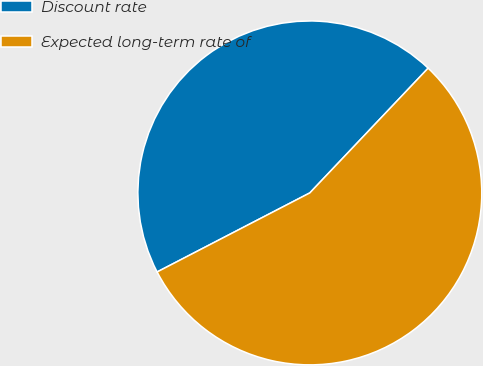Convert chart to OTSL. <chart><loc_0><loc_0><loc_500><loc_500><pie_chart><fcel>Discount rate<fcel>Expected long-term rate of<nl><fcel>44.68%<fcel>55.32%<nl></chart> 